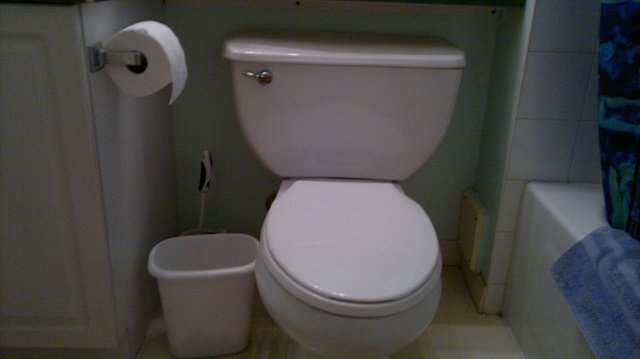Describe the objects in this image and their specific colors. I can see a toilet in black, gray, and darkgray tones in this image. 